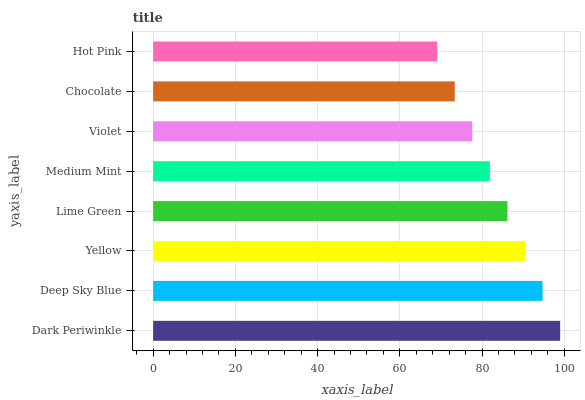Is Hot Pink the minimum?
Answer yes or no. Yes. Is Dark Periwinkle the maximum?
Answer yes or no. Yes. Is Deep Sky Blue the minimum?
Answer yes or no. No. Is Deep Sky Blue the maximum?
Answer yes or no. No. Is Dark Periwinkle greater than Deep Sky Blue?
Answer yes or no. Yes. Is Deep Sky Blue less than Dark Periwinkle?
Answer yes or no. Yes. Is Deep Sky Blue greater than Dark Periwinkle?
Answer yes or no. No. Is Dark Periwinkle less than Deep Sky Blue?
Answer yes or no. No. Is Lime Green the high median?
Answer yes or no. Yes. Is Medium Mint the low median?
Answer yes or no. Yes. Is Medium Mint the high median?
Answer yes or no. No. Is Chocolate the low median?
Answer yes or no. No. 